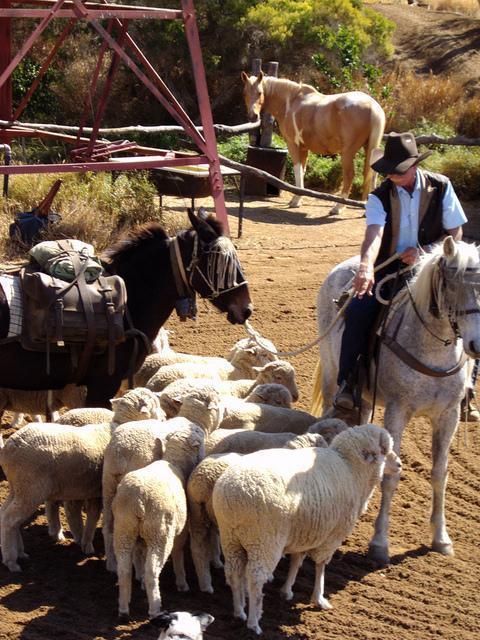What other animal could help here?
Pick the correct solution from the four options below to address the question.
Options: Snakes, bees, cats, dogs. Dogs. 